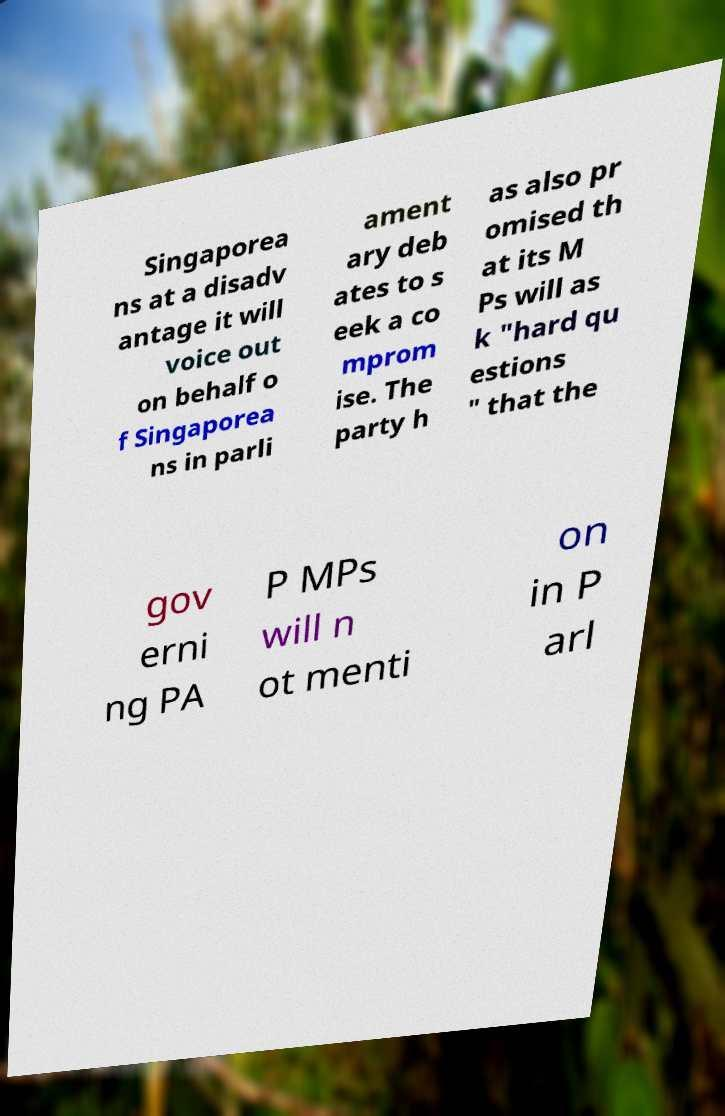Can you read and provide the text displayed in the image?This photo seems to have some interesting text. Can you extract and type it out for me? Singaporea ns at a disadv antage it will voice out on behalf o f Singaporea ns in parli ament ary deb ates to s eek a co mprom ise. The party h as also pr omised th at its M Ps will as k "hard qu estions " that the gov erni ng PA P MPs will n ot menti on in P arl 